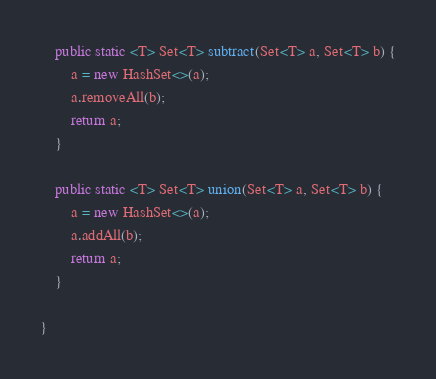<code> <loc_0><loc_0><loc_500><loc_500><_Java_>
    public static <T> Set<T> subtract(Set<T> a, Set<T> b) {
        a = new HashSet<>(a);
        a.removeAll(b);
        return a;
    }

    public static <T> Set<T> union(Set<T> a, Set<T> b) {
        a = new HashSet<>(a);
        a.addAll(b);
        return a;
    }

}
</code> 